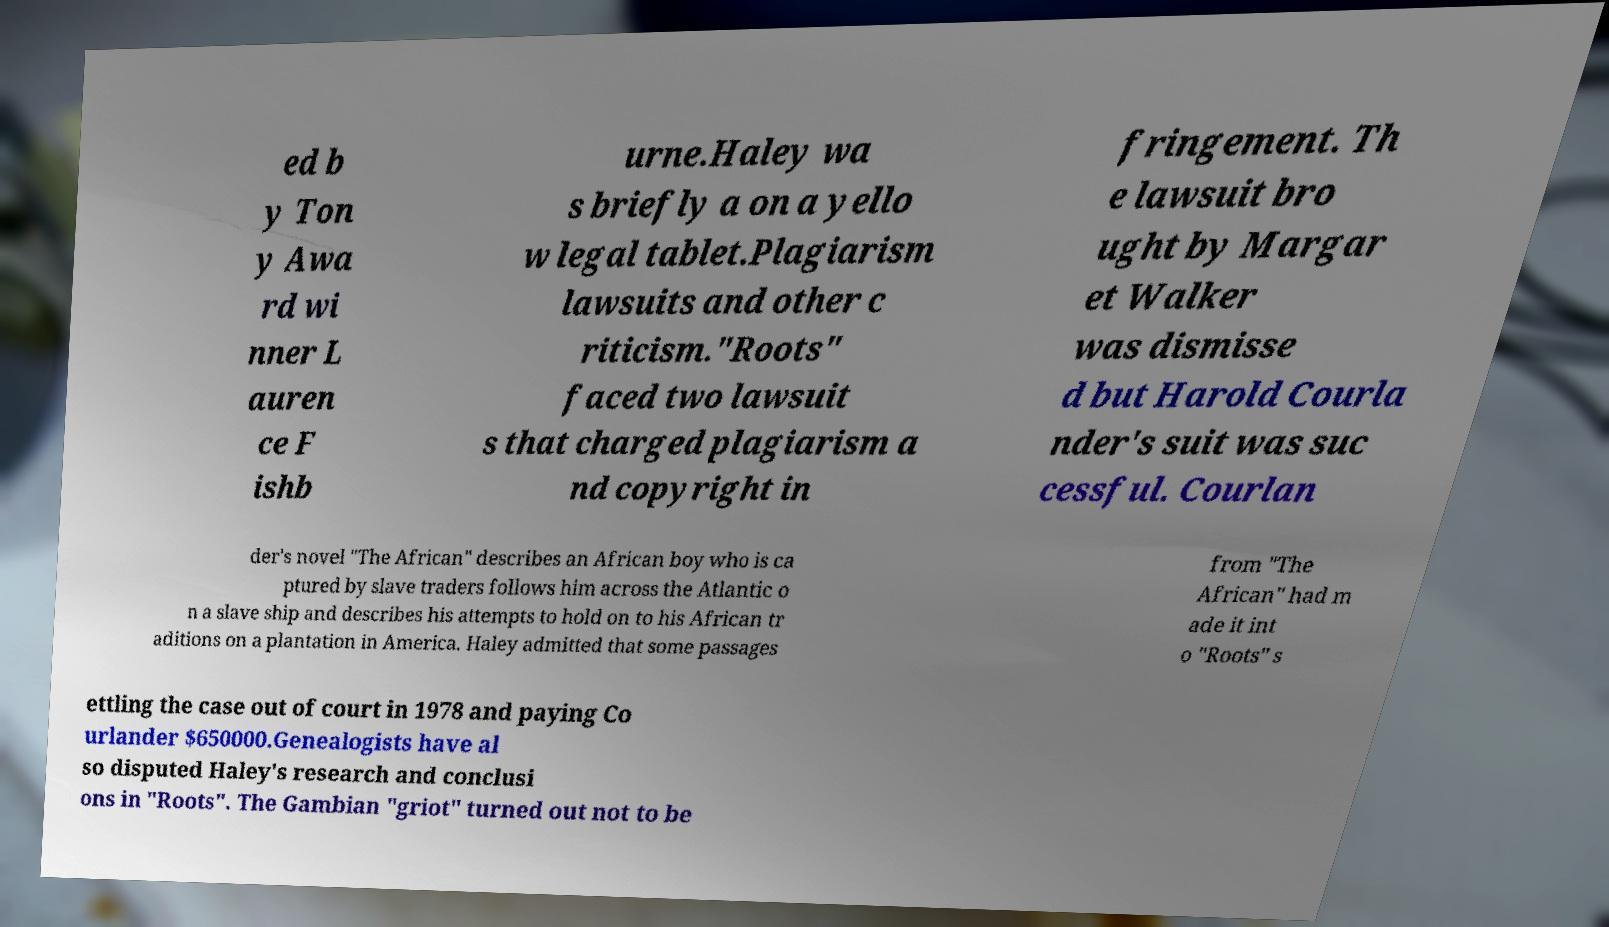For documentation purposes, I need the text within this image transcribed. Could you provide that? ed b y Ton y Awa rd wi nner L auren ce F ishb urne.Haley wa s briefly a on a yello w legal tablet.Plagiarism lawsuits and other c riticism."Roots" faced two lawsuit s that charged plagiarism a nd copyright in fringement. Th e lawsuit bro ught by Margar et Walker was dismisse d but Harold Courla nder's suit was suc cessful. Courlan der's novel "The African" describes an African boy who is ca ptured by slave traders follows him across the Atlantic o n a slave ship and describes his attempts to hold on to his African tr aditions on a plantation in America. Haley admitted that some passages from "The African" had m ade it int o "Roots" s ettling the case out of court in 1978 and paying Co urlander $650000.Genealogists have al so disputed Haley's research and conclusi ons in "Roots". The Gambian "griot" turned out not to be 